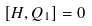Convert formula to latex. <formula><loc_0><loc_0><loc_500><loc_500>[ H , Q _ { 1 } ] = 0</formula> 